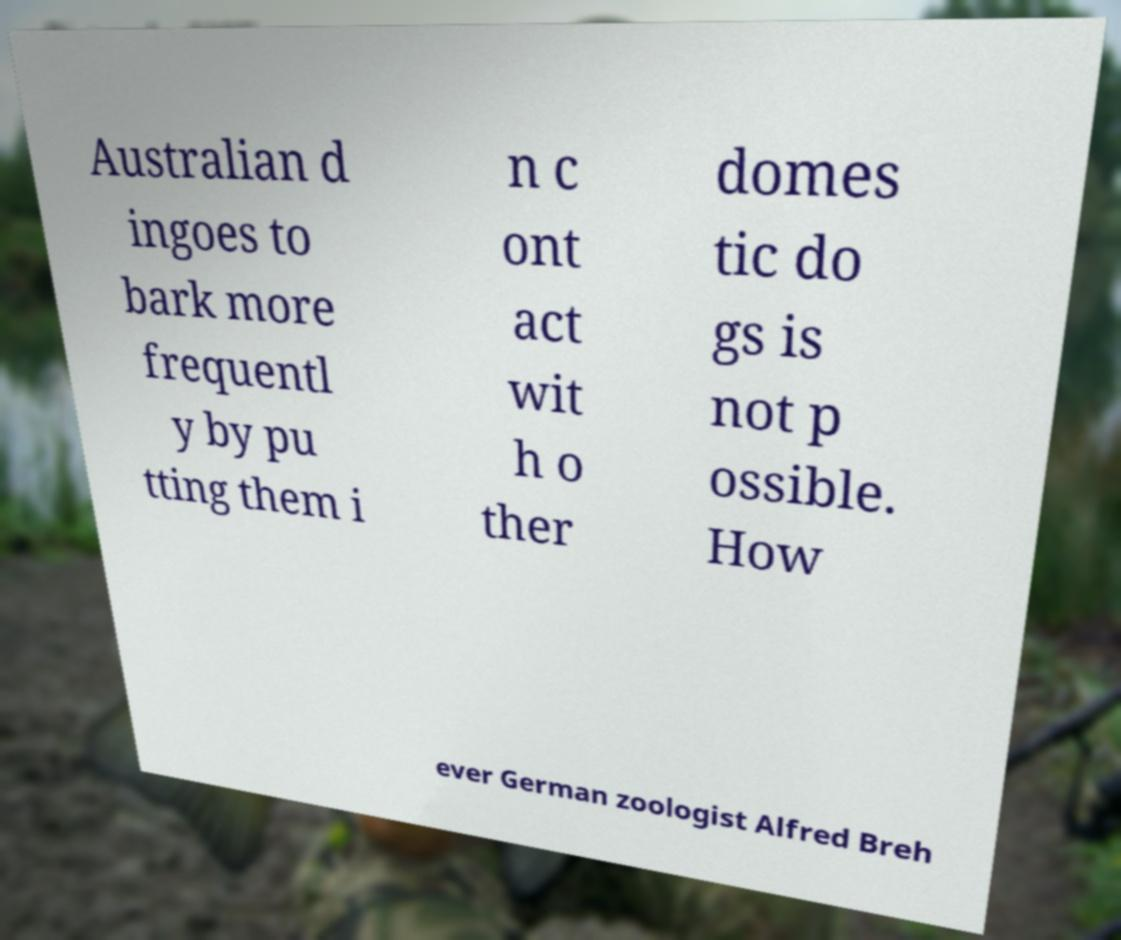What messages or text are displayed in this image? I need them in a readable, typed format. Australian d ingoes to bark more frequentl y by pu tting them i n c ont act wit h o ther domes tic do gs is not p ossible. How ever German zoologist Alfred Breh 